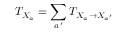<formula> <loc_0><loc_0><loc_500><loc_500>T _ { X _ { a } } = \sum _ { a ^ { \prime } } T _ { X _ { a } \rightarrow X _ { a ^ { \prime } } }</formula> 